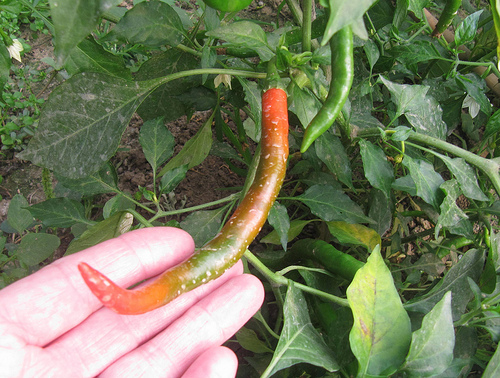<image>
Can you confirm if the pepper is on the ground? No. The pepper is not positioned on the ground. They may be near each other, but the pepper is not supported by or resting on top of the ground. Is there a chilli above the finger? Yes. The chilli is positioned above the finger in the vertical space, higher up in the scene. 